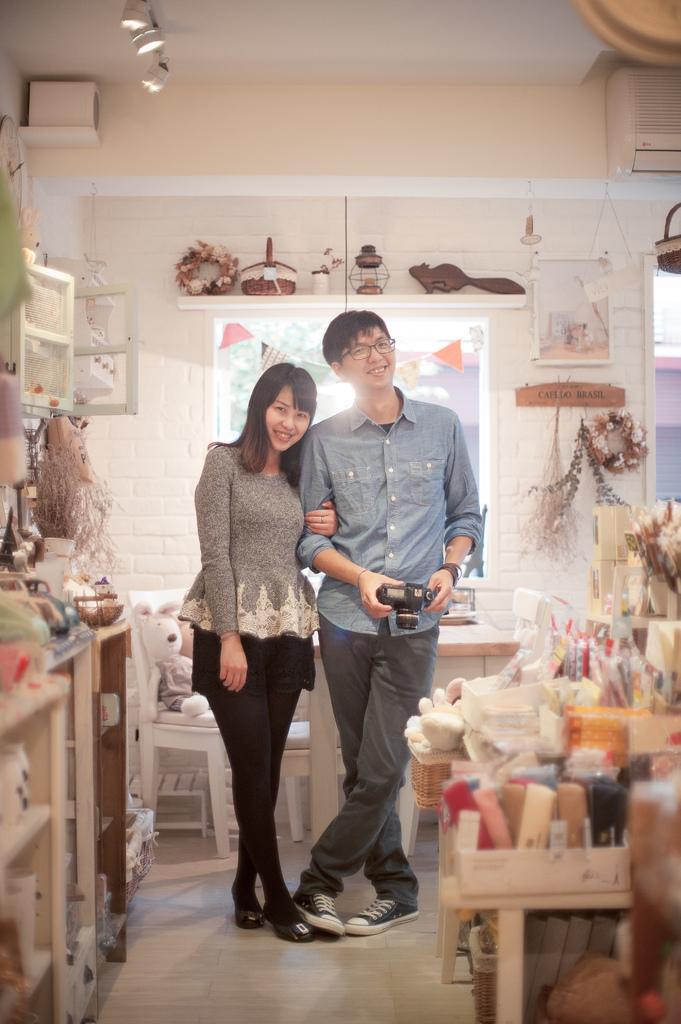Can you describe this image briefly? A couple are posing to camera. Of them the man holds camera in his hand. 